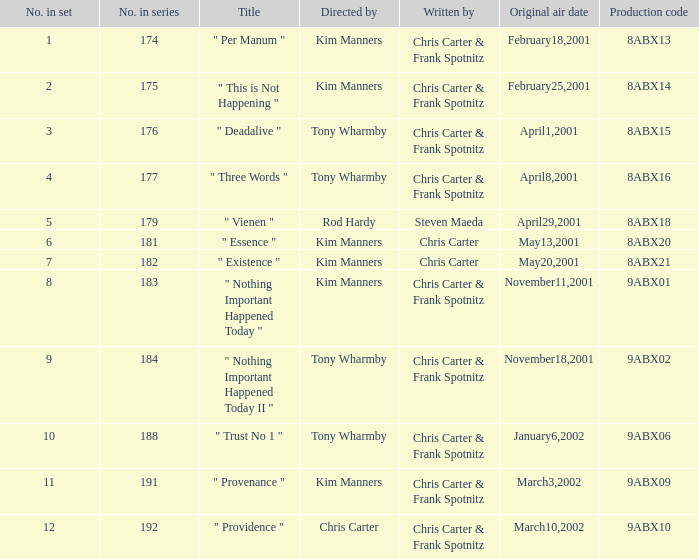The episode with production code 9abx02 was originally aired on what date? November18,2001. 